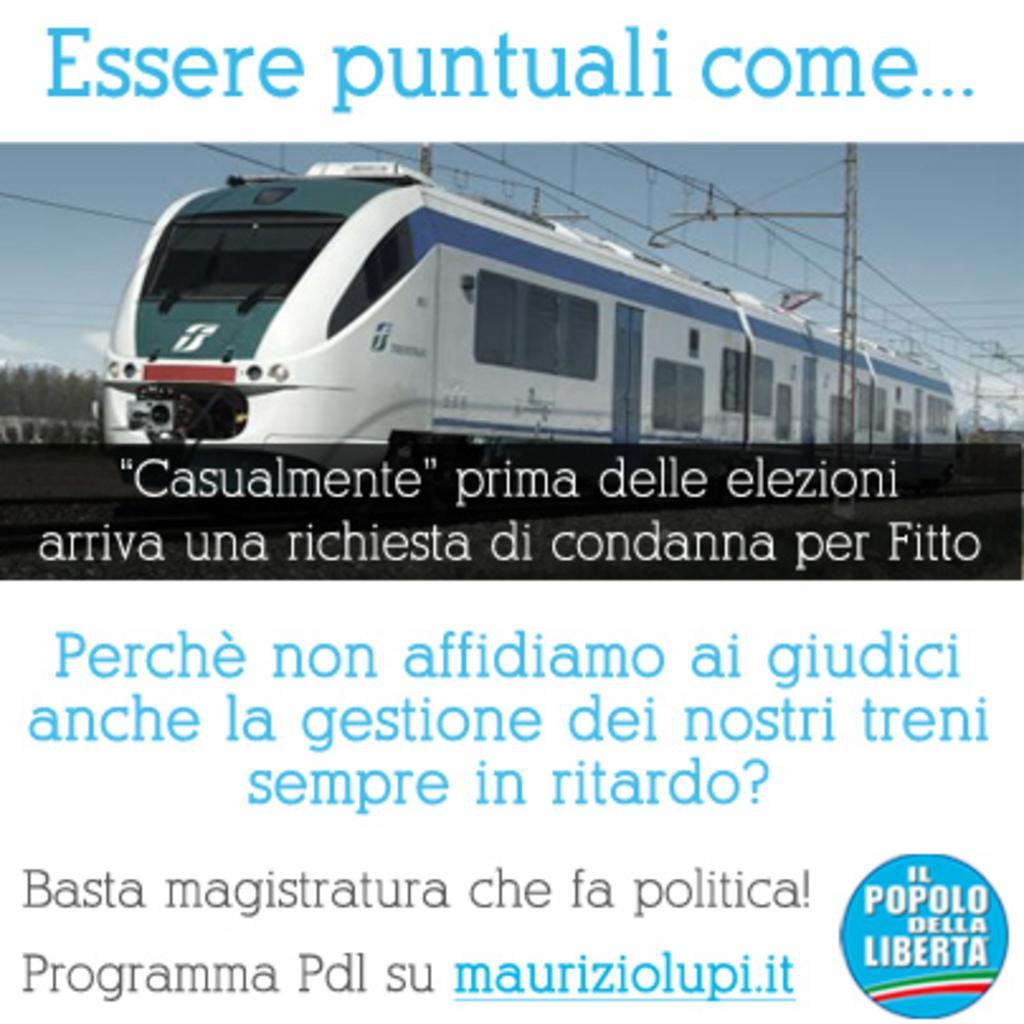Please provide a concise description of this image. In this image I can see a poster. There is a logo , there are words, there is a image of a train, poles, cables, trees and sky on the poster. 